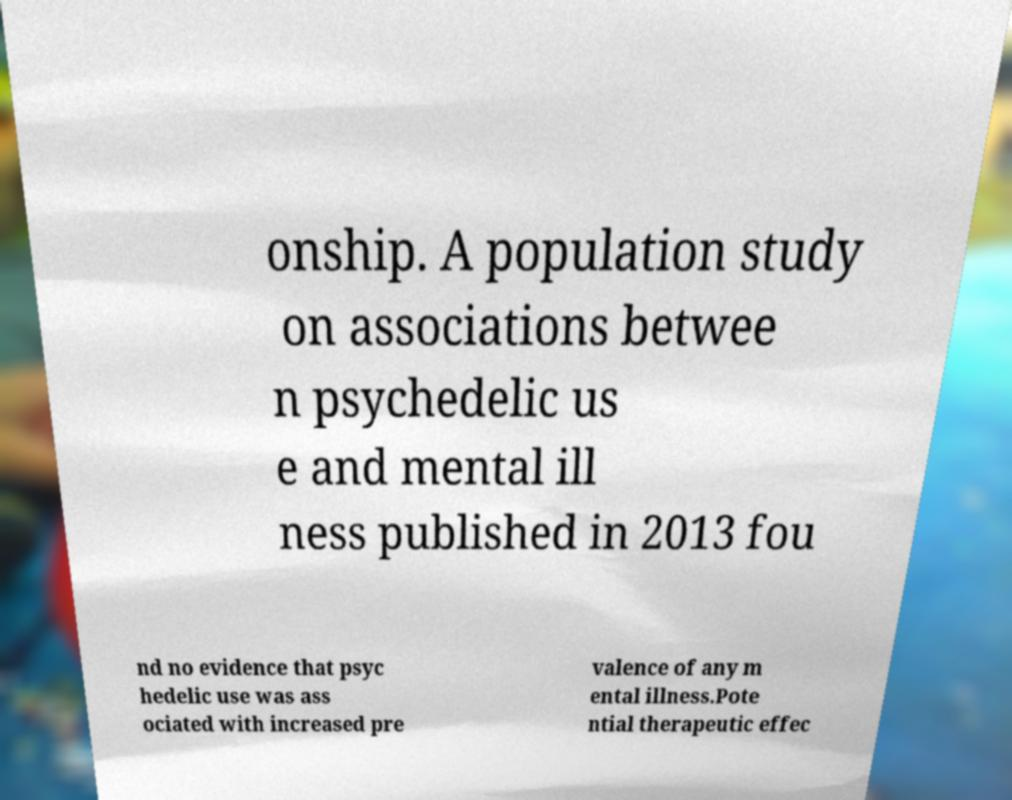For documentation purposes, I need the text within this image transcribed. Could you provide that? onship. A population study on associations betwee n psychedelic us e and mental ill ness published in 2013 fou nd no evidence that psyc hedelic use was ass ociated with increased pre valence of any m ental illness.Pote ntial therapeutic effec 